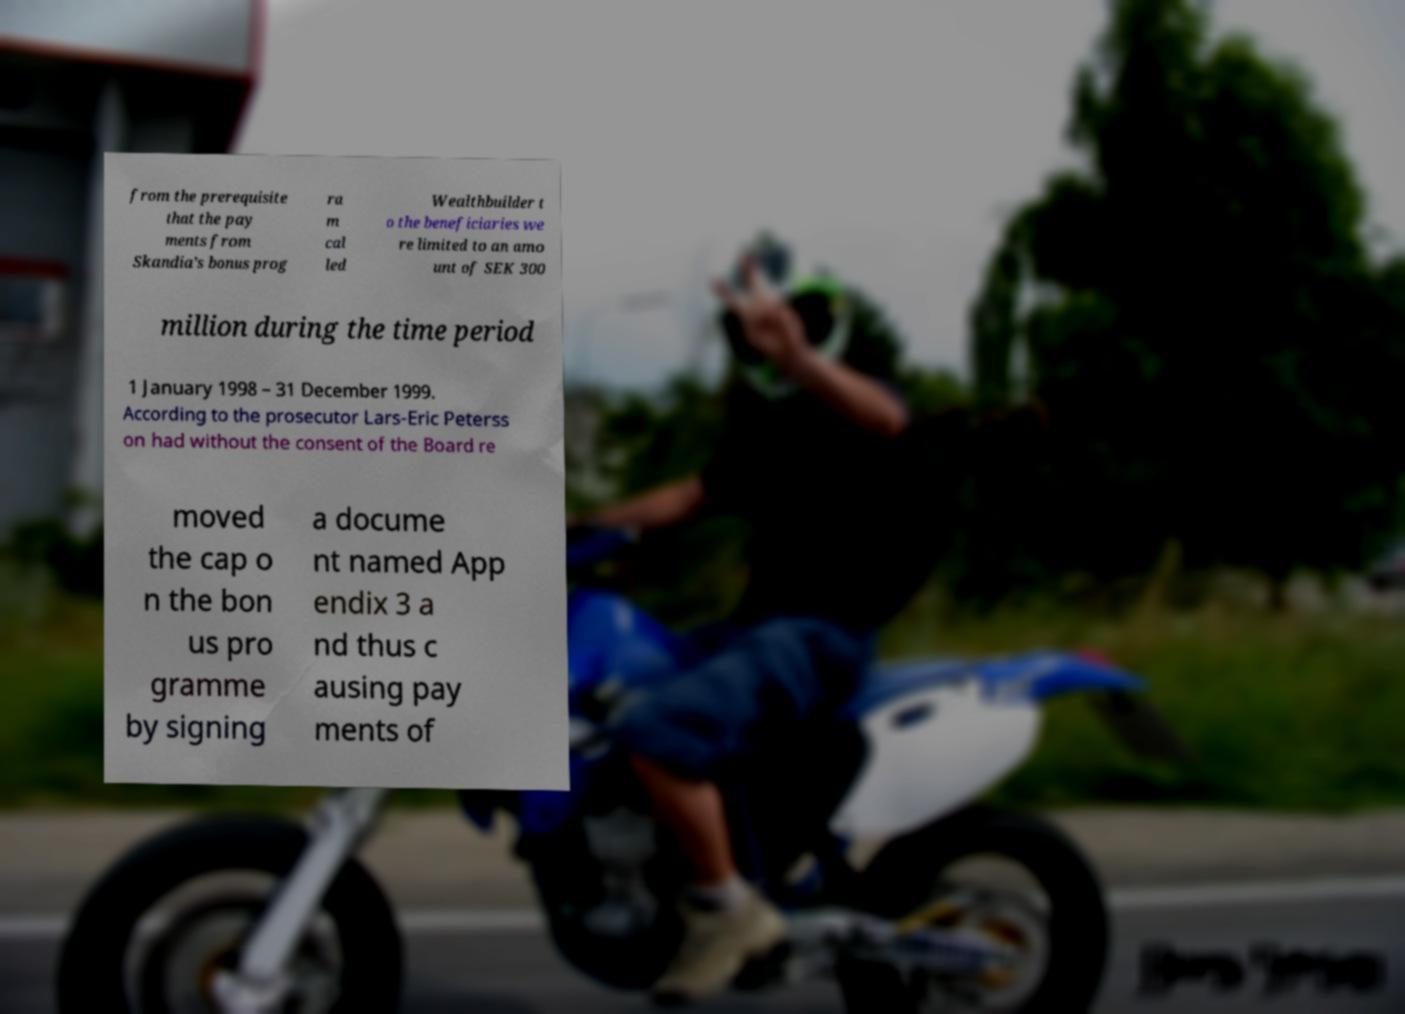Could you assist in decoding the text presented in this image and type it out clearly? from the prerequisite that the pay ments from Skandia’s bonus prog ra m cal led Wealthbuilder t o the beneficiaries we re limited to an amo unt of SEK 300 million during the time period 1 January 1998 – 31 December 1999. According to the prosecutor Lars-Eric Peterss on had without the consent of the Board re moved the cap o n the bon us pro gramme by signing a docume nt named App endix 3 a nd thus c ausing pay ments of 